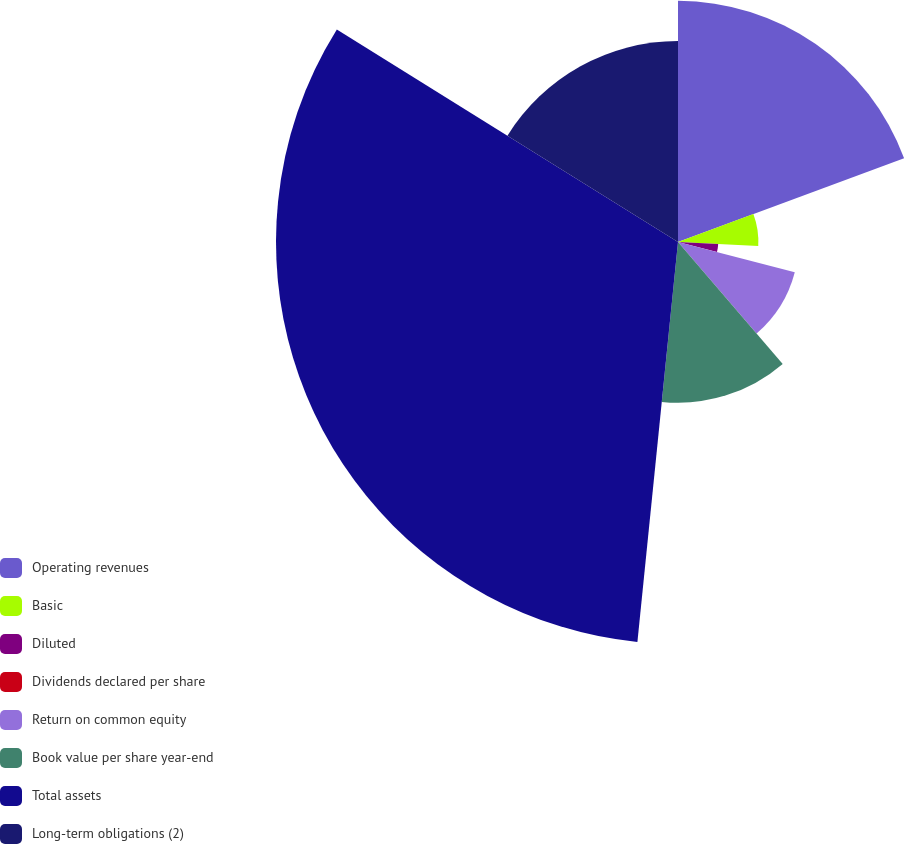Convert chart. <chart><loc_0><loc_0><loc_500><loc_500><pie_chart><fcel>Operating revenues<fcel>Basic<fcel>Diluted<fcel>Dividends declared per share<fcel>Return on common equity<fcel>Book value per share year-end<fcel>Total assets<fcel>Long-term obligations (2)<nl><fcel>19.35%<fcel>6.45%<fcel>3.23%<fcel>0.0%<fcel>9.68%<fcel>12.9%<fcel>32.26%<fcel>16.13%<nl></chart> 